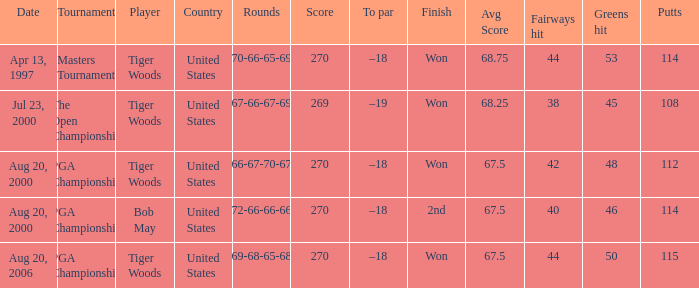What players finished 2nd? Bob May. Give me the full table as a dictionary. {'header': ['Date', 'Tournament', 'Player', 'Country', 'Rounds', 'Score', 'To par', 'Finish', 'Avg Score', 'Fairways hit', 'Greens hit', 'Putts'], 'rows': [['Apr 13, 1997', 'Masters Tournament', 'Tiger Woods', 'United States', '70-66-65-69', '270', '–18', 'Won', '68.75', '44', '53', '114'], ['Jul 23, 2000', 'The Open Championship', 'Tiger Woods', 'United States', '67-66-67-69', '269', '–19', 'Won', '68.25', '38', '45', '108'], ['Aug 20, 2000', 'PGA Championship', 'Tiger Woods', 'United States', '66-67-70-67', '270', '–18', 'Won', '67.5', '42', '48', '112'], ['Aug 20, 2000', 'PGA Championship', 'Bob May', 'United States', '72-66-66-66', '270', '–18', '2nd', '67.5', '40', '46', '114'], ['Aug 20, 2006', 'PGA Championship', 'Tiger Woods', 'United States', '69-68-65-68', '270', '–18', 'Won', '67.5', '44', '50', '115']]} 